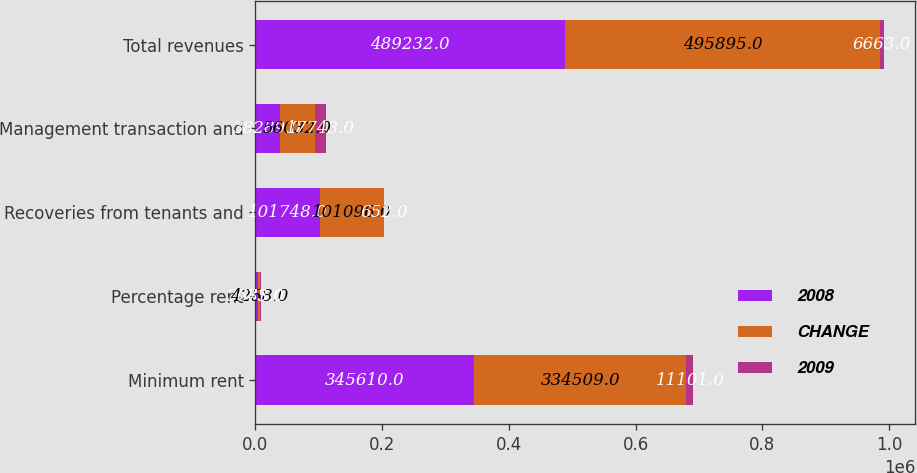Convert chart to OTSL. <chart><loc_0><loc_0><loc_500><loc_500><stacked_bar_chart><ecel><fcel>Minimum rent<fcel>Percentage rent<fcel>Recoveries from tenants and<fcel>Management transaction and<fcel>Total revenues<nl><fcel>2008<fcel>345610<fcel>3585<fcel>101748<fcel>38289<fcel>489232<nl><fcel>CHANGE<fcel>334509<fcel>4258<fcel>101096<fcel>56032<fcel>495895<nl><fcel>2009<fcel>11101<fcel>673<fcel>652<fcel>17743<fcel>6663<nl></chart> 